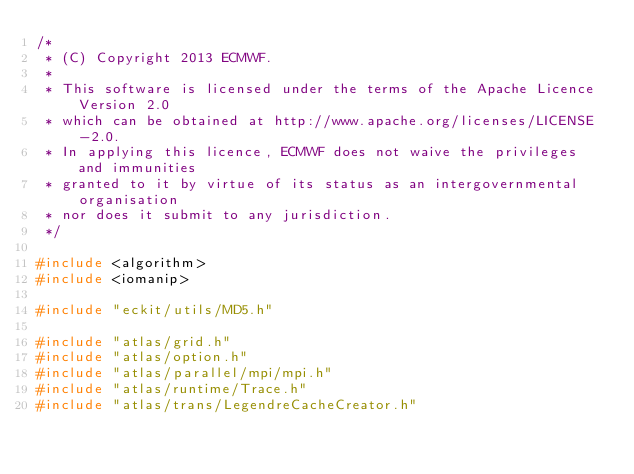Convert code to text. <code><loc_0><loc_0><loc_500><loc_500><_C++_>/*
 * (C) Copyright 2013 ECMWF.
 *
 * This software is licensed under the terms of the Apache Licence Version 2.0
 * which can be obtained at http://www.apache.org/licenses/LICENSE-2.0.
 * In applying this licence, ECMWF does not waive the privileges and immunities
 * granted to it by virtue of its status as an intergovernmental organisation
 * nor does it submit to any jurisdiction.
 */

#include <algorithm>
#include <iomanip>

#include "eckit/utils/MD5.h"

#include "atlas/grid.h"
#include "atlas/option.h"
#include "atlas/parallel/mpi/mpi.h"
#include "atlas/runtime/Trace.h"
#include "atlas/trans/LegendreCacheCreator.h"</code> 